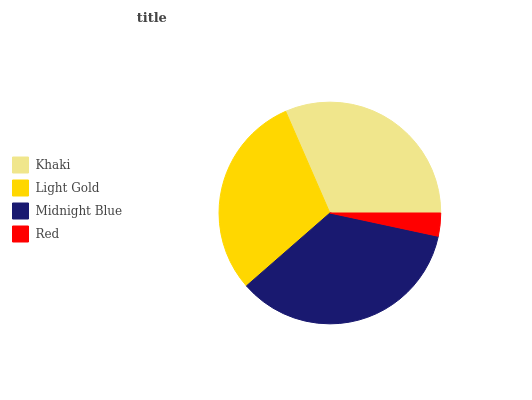Is Red the minimum?
Answer yes or no. Yes. Is Midnight Blue the maximum?
Answer yes or no. Yes. Is Light Gold the minimum?
Answer yes or no. No. Is Light Gold the maximum?
Answer yes or no. No. Is Khaki greater than Light Gold?
Answer yes or no. Yes. Is Light Gold less than Khaki?
Answer yes or no. Yes. Is Light Gold greater than Khaki?
Answer yes or no. No. Is Khaki less than Light Gold?
Answer yes or no. No. Is Khaki the high median?
Answer yes or no. Yes. Is Light Gold the low median?
Answer yes or no. Yes. Is Light Gold the high median?
Answer yes or no. No. Is Khaki the low median?
Answer yes or no. No. 